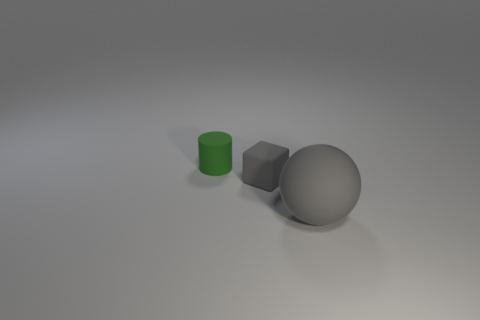Add 1 small purple metal spheres. How many objects exist? 4 Subtract all cylinders. How many objects are left? 2 Subtract all large matte balls. Subtract all small cyan rubber balls. How many objects are left? 2 Add 1 small cylinders. How many small cylinders are left? 2 Add 3 large gray rubber balls. How many large gray rubber balls exist? 4 Subtract 0 gray cylinders. How many objects are left? 3 